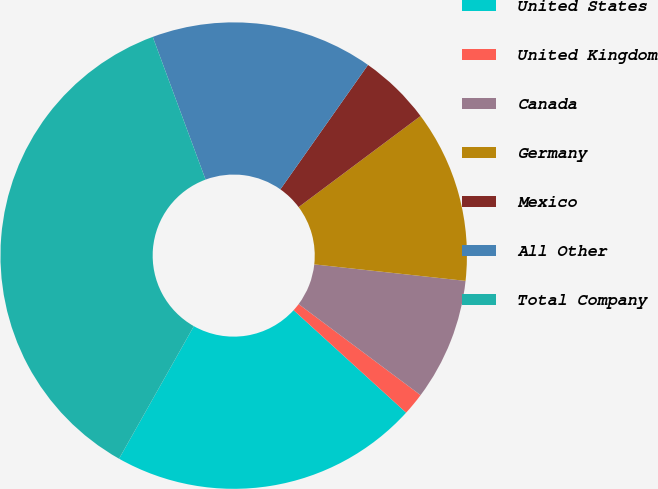Convert chart. <chart><loc_0><loc_0><loc_500><loc_500><pie_chart><fcel>United States<fcel>United Kingdom<fcel>Canada<fcel>Germany<fcel>Mexico<fcel>All Other<fcel>Total Company<nl><fcel>21.42%<fcel>1.55%<fcel>8.48%<fcel>11.94%<fcel>5.02%<fcel>15.41%<fcel>36.18%<nl></chart> 